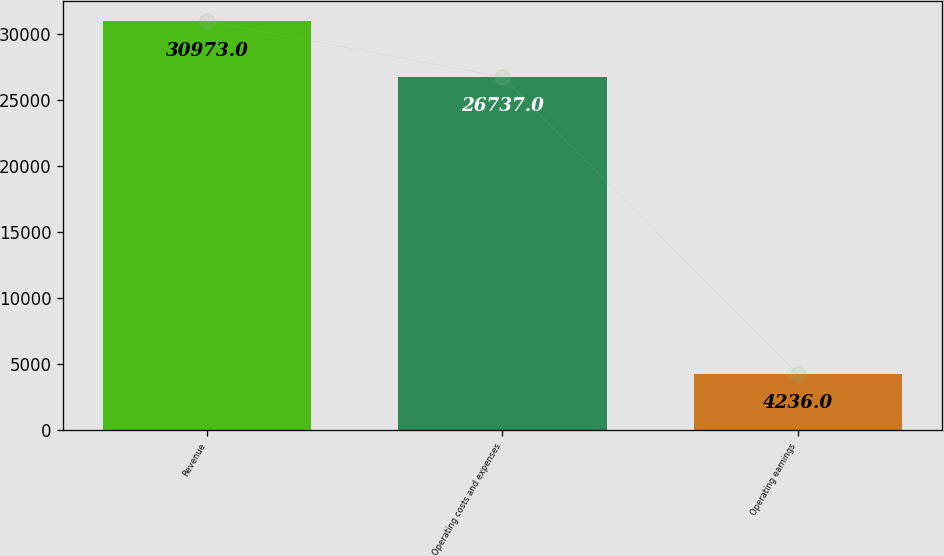<chart> <loc_0><loc_0><loc_500><loc_500><bar_chart><fcel>Revenue<fcel>Operating costs and expenses<fcel>Operating earnings<nl><fcel>30973<fcel>26737<fcel>4236<nl></chart> 